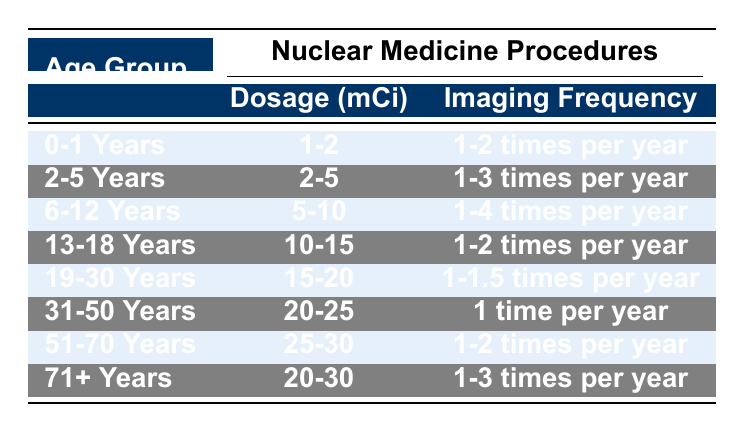What is the dosage for the age group 6-12 years? The table states that for the age group 6-12 years, the dosage is 5-10 mCi, which is directly referenced in the Dosage column next to that age group.
Answer: 5-10 mCi How many times per year do patients aged 2-5 years undergo imaging? For the age group of 2-5 years, the table indicates that imaging frequency is 1-3 times per year, as shown in the Imaging Frequency column corresponding to that age group.
Answer: 1-3 times per year Is the imaging frequency for the age group 31-50 years greater than that for the age group 51-70 years? The imaging frequency for 31-50 years is 1 time per year, while for 51-70 years, it is 1-2 times per year. Since 1-2 times is greater than 1 time, the statement is true.
Answer: Yes What is the average dosage of nuclear medicine procedures for all age groups? The dosages for all age groups are: 1-2 mCi, 2-5 mCi, 5-10 mCi, 10-15 mCi, 15-20 mCi, 20-25 mCi, 25-30 mCi, and 20-30 mCi. To find the average, we use the midpoint of each range: (1.5 + 3.5 + 7.5 + 12.5 + 17.5 + 22.5 + 27.5 + 25) / 8 = 13.75 mCi.
Answer: 13.75 mCi Is the dosage for patients aged 71 and older the same as that for the 19-30 years age group? The table shows that the dosage for the 71 and older age group is 20-30 mCi, and for the 19-30 years group, it is 15-20 mCi. Since these ranges do not match, the answer is no.
Answer: No How does the imaging frequency of the 13-18 years age group compare to that of the 0-1 years age group? The imaging frequency for the 13-18 years age group is 1-2 times per year, whereas for the 0-1 years age group, it is 1-2 times per year as well. Since both frequencies are the same, the answer is that they are equal.
Answer: Equal 